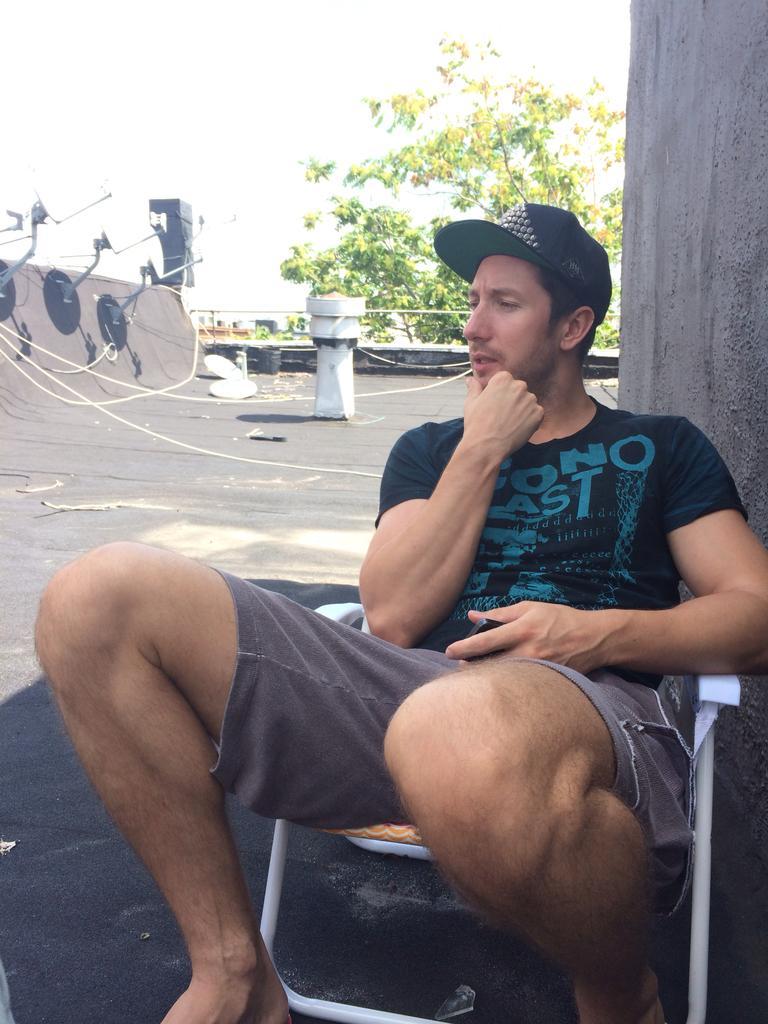Could you give a brief overview of what you see in this image? In this image we can see a person sitting on a chair. Behind the person we can see a wall and a tree. On the left side, we can see few objects. At the top we can see the sky. 